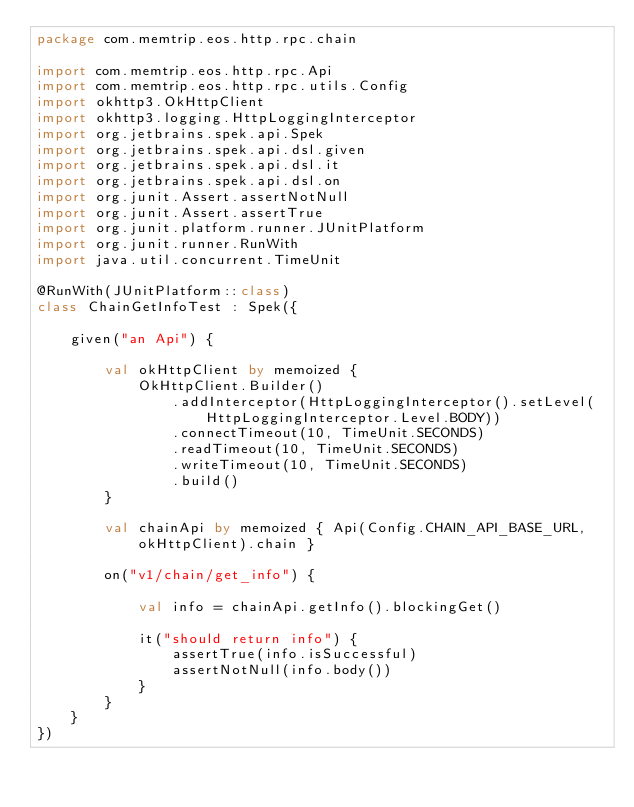<code> <loc_0><loc_0><loc_500><loc_500><_Kotlin_>package com.memtrip.eos.http.rpc.chain

import com.memtrip.eos.http.rpc.Api
import com.memtrip.eos.http.rpc.utils.Config
import okhttp3.OkHttpClient
import okhttp3.logging.HttpLoggingInterceptor
import org.jetbrains.spek.api.Spek
import org.jetbrains.spek.api.dsl.given
import org.jetbrains.spek.api.dsl.it
import org.jetbrains.spek.api.dsl.on
import org.junit.Assert.assertNotNull
import org.junit.Assert.assertTrue
import org.junit.platform.runner.JUnitPlatform
import org.junit.runner.RunWith
import java.util.concurrent.TimeUnit

@RunWith(JUnitPlatform::class)
class ChainGetInfoTest : Spek({

    given("an Api") {

        val okHttpClient by memoized {
            OkHttpClient.Builder()
                .addInterceptor(HttpLoggingInterceptor().setLevel(HttpLoggingInterceptor.Level.BODY))
                .connectTimeout(10, TimeUnit.SECONDS)
                .readTimeout(10, TimeUnit.SECONDS)
                .writeTimeout(10, TimeUnit.SECONDS)
                .build()
        }

        val chainApi by memoized { Api(Config.CHAIN_API_BASE_URL, okHttpClient).chain }

        on("v1/chain/get_info") {

            val info = chainApi.getInfo().blockingGet()

            it("should return info") {
                assertTrue(info.isSuccessful)
                assertNotNull(info.body())
            }
        }
    }
})</code> 